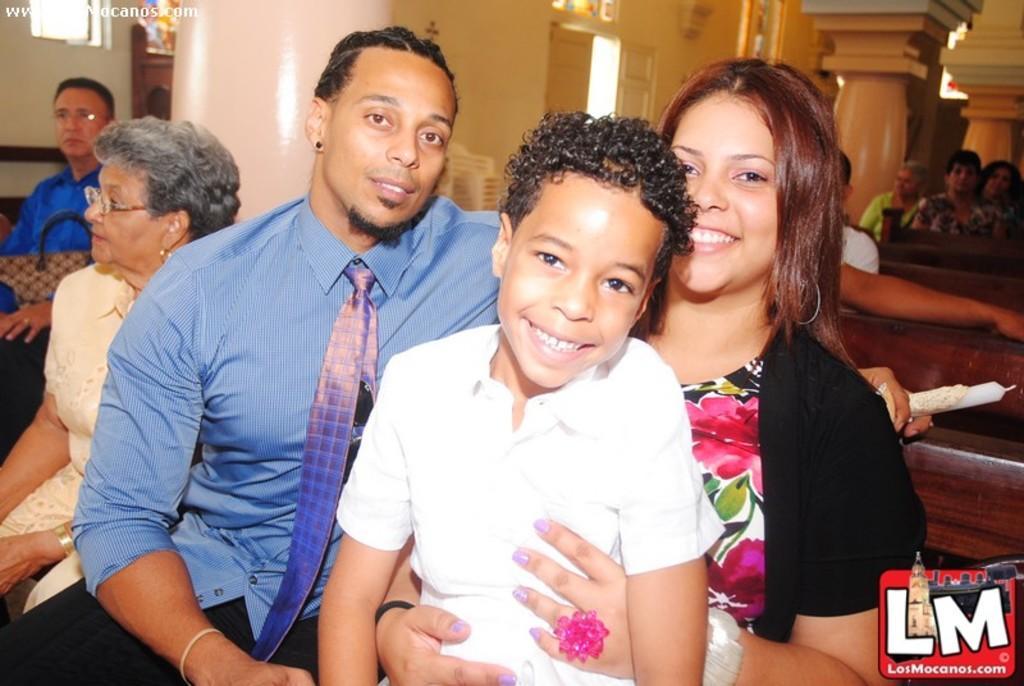Describe this image in one or two sentences. In the image I can see people are sitting on benches among them the people in front of the image are smiling. In the background I can see a pillar, wall and some other. I can also see watermark and a logo on the image. 